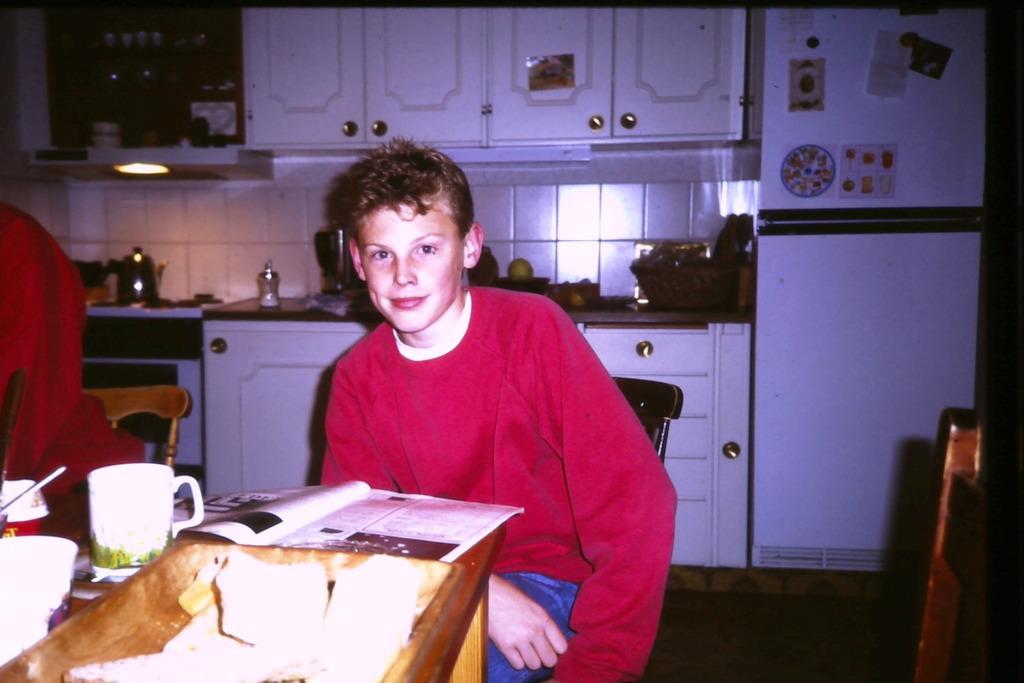Describe this image in one or two sentences. In this picture we can see man smiling and sitting on chair and in front of them there is table and on table we can see cup, book, tray and in background we can see cupboards, desk, refrigerator stickers to it, kettle. 